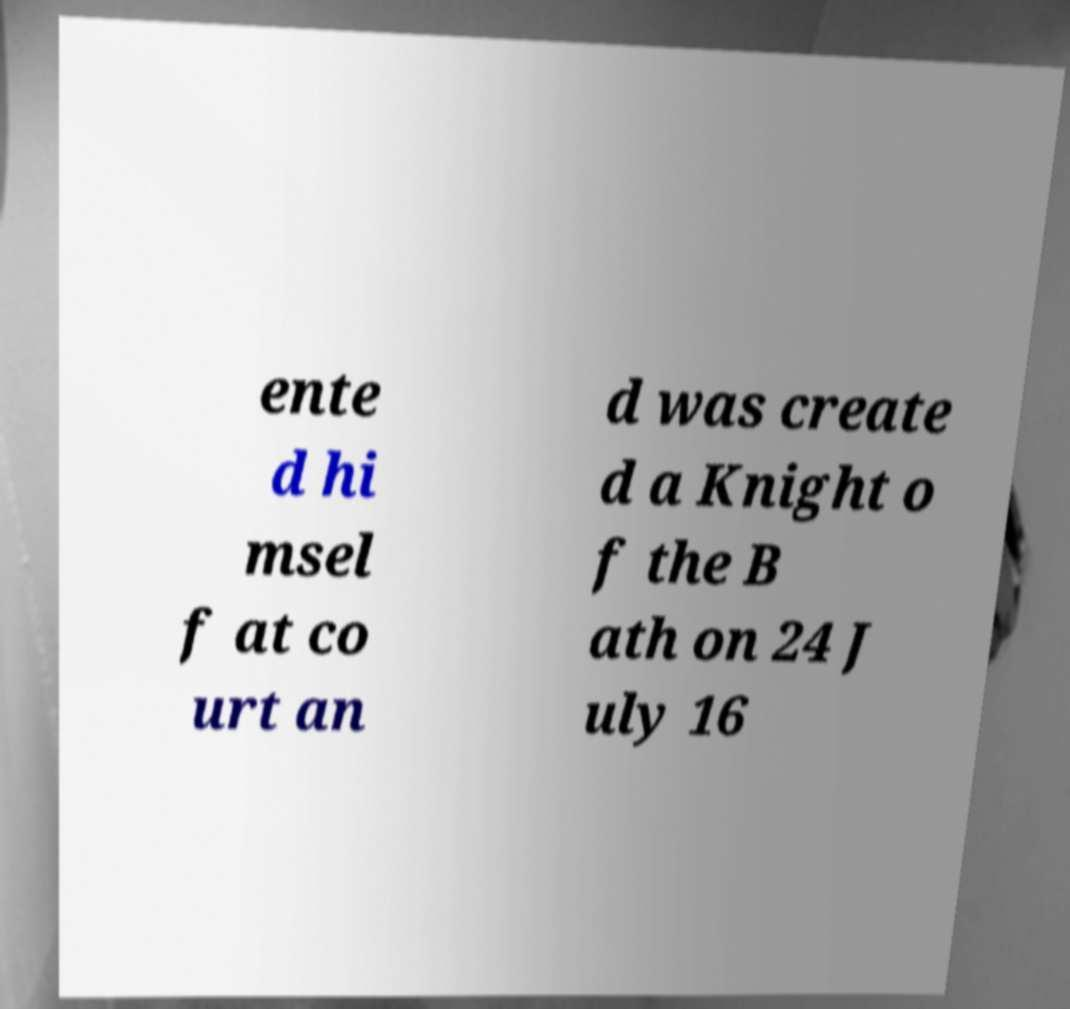For documentation purposes, I need the text within this image transcribed. Could you provide that? ente d hi msel f at co urt an d was create d a Knight o f the B ath on 24 J uly 16 